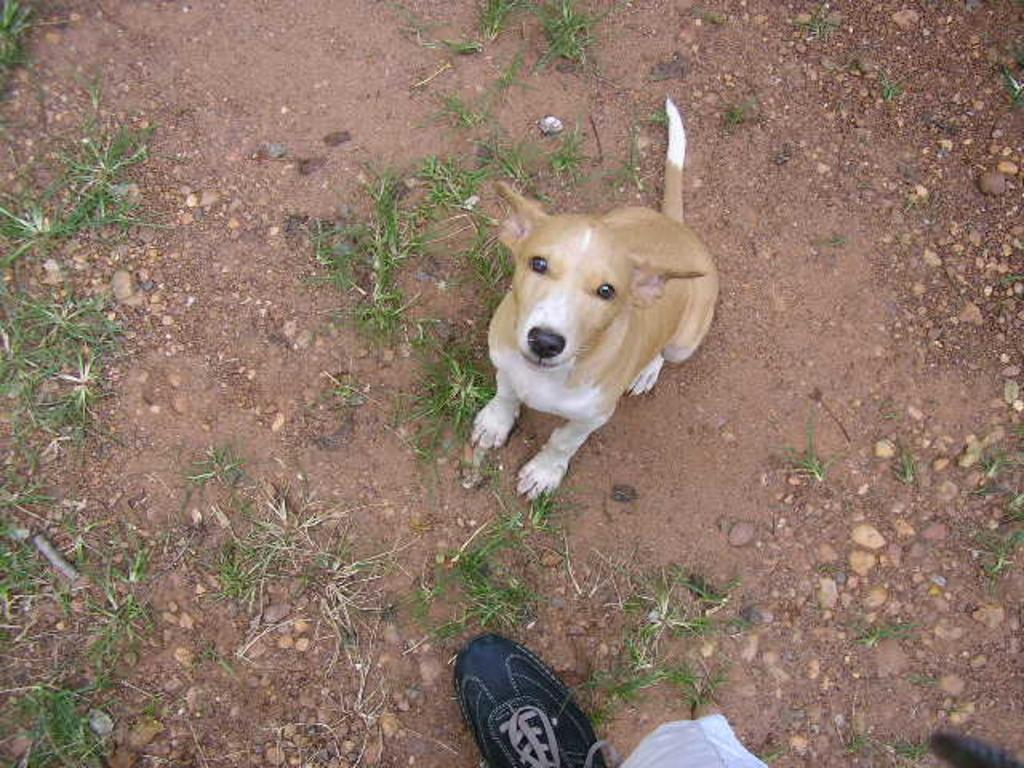What type of animal is present in the image? There is a dog in the image. What other object can be seen in the image? There is a shoe in the image. What is on the ground in the image? There are stones on the ground in the image. What type of vegetation is visible in the image? There is grass in the image. What type of structure is the dog wishing to build in the image? There is no indication in the image that the dog is wishing to build any structure. How many drops of water can be seen falling from the sky in the image? There is no rain or water drops visible in the image. 